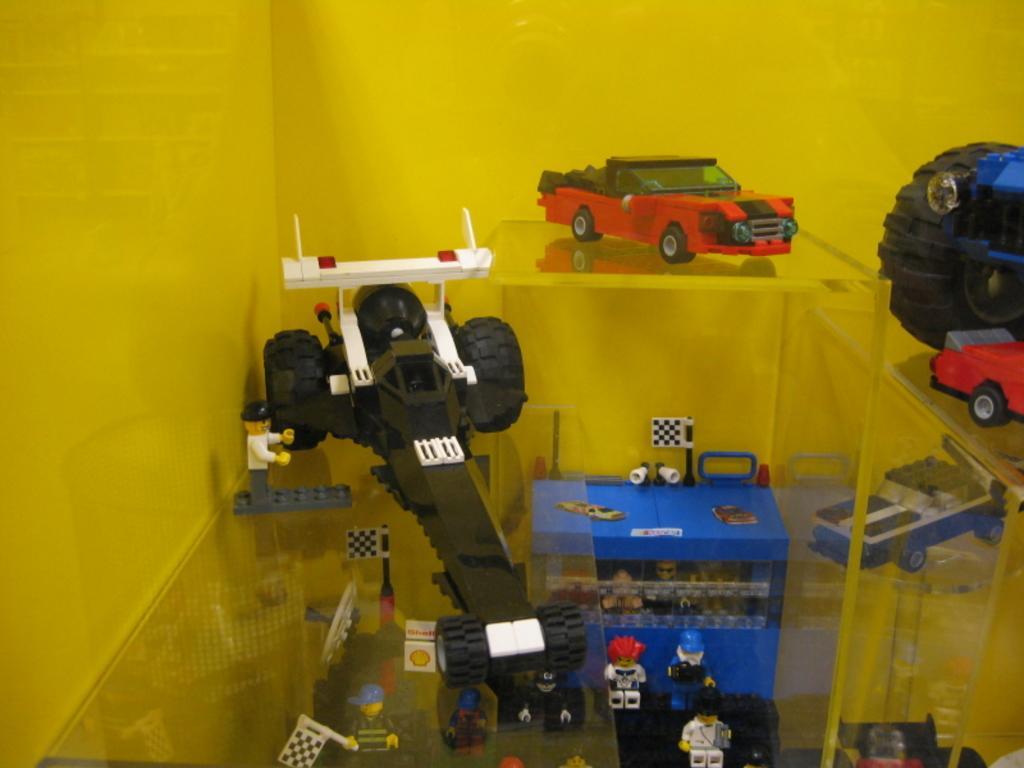How would you summarize this image in a sentence or two? In this picture I can see toys of cars and other objects. These objects are on a glass table. In the background I can see a yellow color wall. 